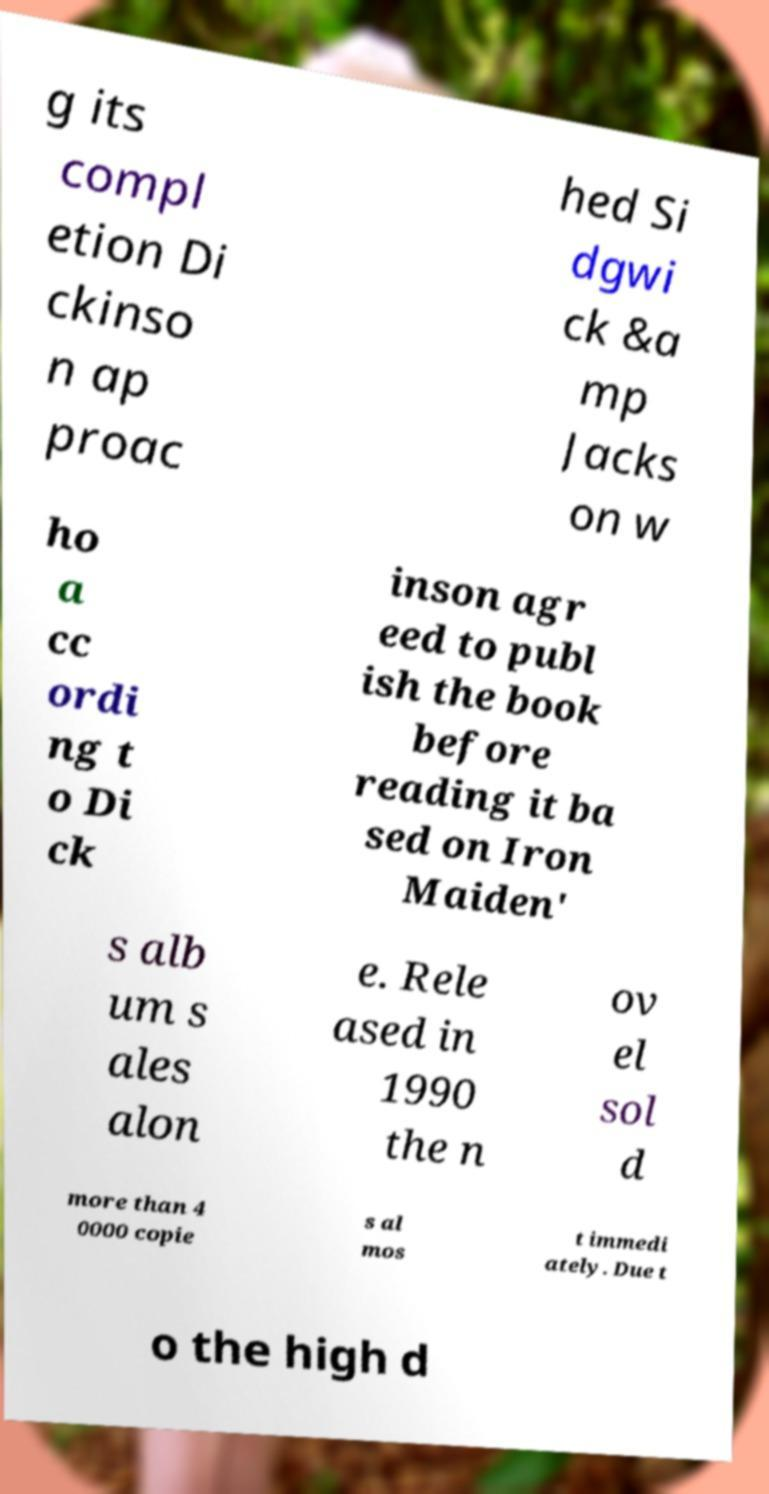Could you extract and type out the text from this image? g its compl etion Di ckinso n ap proac hed Si dgwi ck &a mp Jacks on w ho a cc ordi ng t o Di ck inson agr eed to publ ish the book before reading it ba sed on Iron Maiden' s alb um s ales alon e. Rele ased in 1990 the n ov el sol d more than 4 0000 copie s al mos t immedi ately. Due t o the high d 